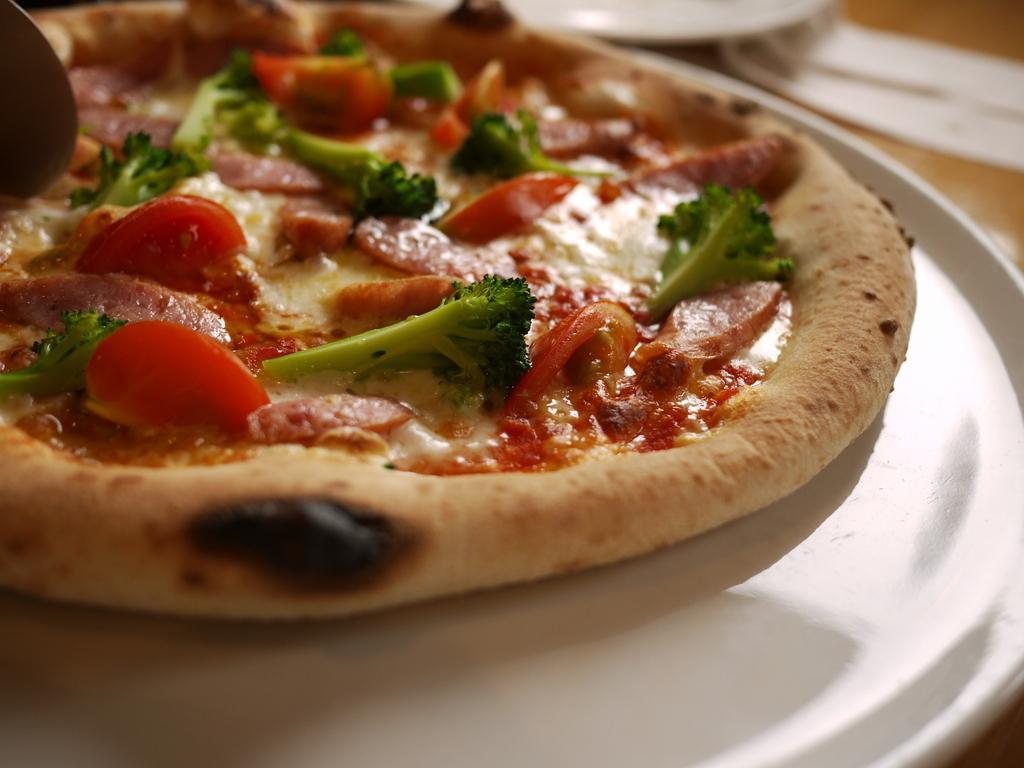How would you summarize this image in a sentence or two? In the foreground of this image, there is a pizza on a white platter. On the top, there is a white object on a wooden surface. 